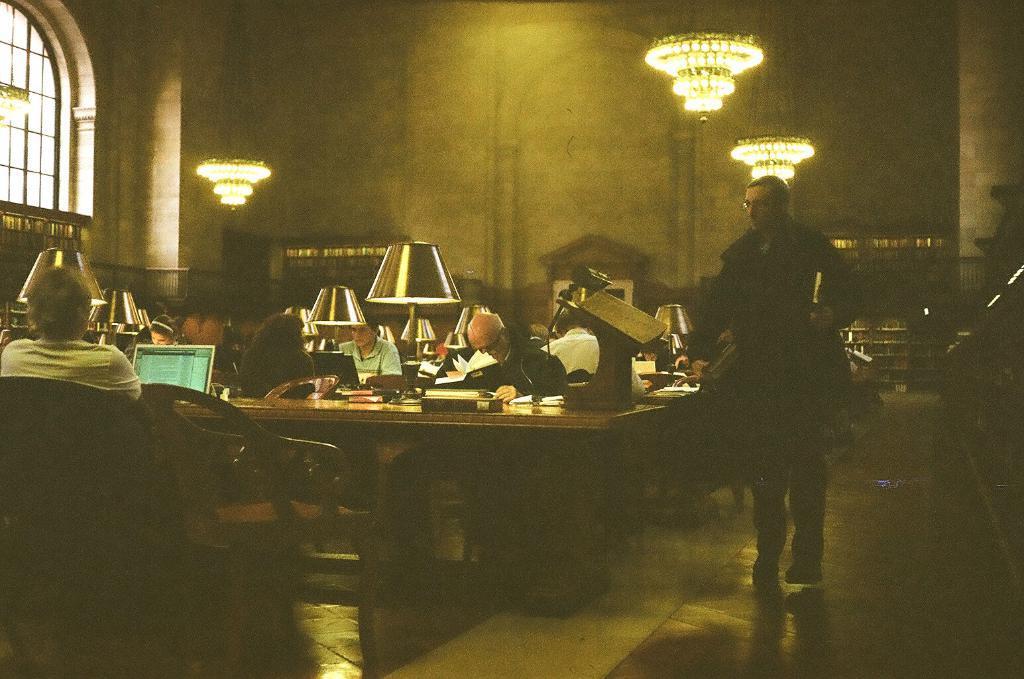Can you describe this image briefly? There is a group of people sitting in a room. On the right side we have a one person. His standing and holding a book. We can see in the background there is a wall,curtain. 